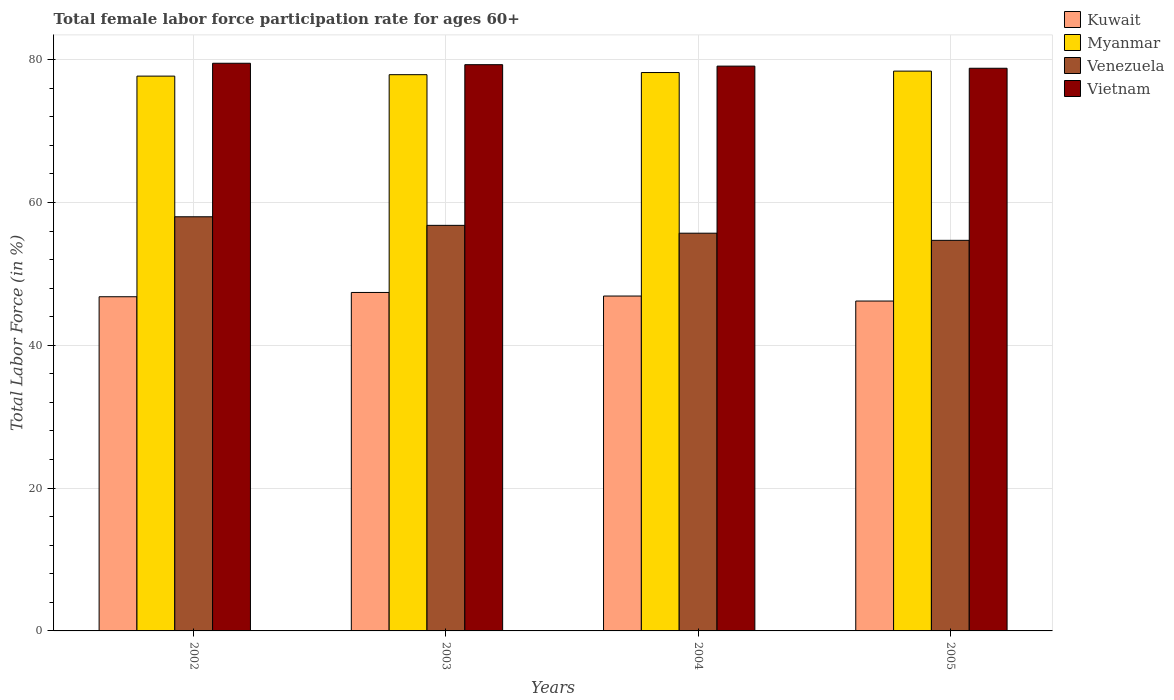How many different coloured bars are there?
Provide a short and direct response. 4. How many groups of bars are there?
Ensure brevity in your answer.  4. Are the number of bars per tick equal to the number of legend labels?
Keep it short and to the point. Yes. How many bars are there on the 3rd tick from the left?
Ensure brevity in your answer.  4. What is the label of the 4th group of bars from the left?
Provide a succinct answer. 2005. What is the female labor force participation rate in Venezuela in 2005?
Offer a terse response. 54.7. Across all years, what is the maximum female labor force participation rate in Kuwait?
Give a very brief answer. 47.4. Across all years, what is the minimum female labor force participation rate in Vietnam?
Ensure brevity in your answer.  78.8. In which year was the female labor force participation rate in Vietnam maximum?
Make the answer very short. 2002. What is the total female labor force participation rate in Venezuela in the graph?
Offer a terse response. 225.2. What is the difference between the female labor force participation rate in Myanmar in 2004 and that in 2005?
Provide a succinct answer. -0.2. What is the difference between the female labor force participation rate in Venezuela in 2002 and the female labor force participation rate in Kuwait in 2004?
Give a very brief answer. 11.1. What is the average female labor force participation rate in Myanmar per year?
Make the answer very short. 78.05. In the year 2003, what is the difference between the female labor force participation rate in Venezuela and female labor force participation rate in Myanmar?
Give a very brief answer. -21.1. What is the ratio of the female labor force participation rate in Venezuela in 2003 to that in 2005?
Keep it short and to the point. 1.04. Is the difference between the female labor force participation rate in Venezuela in 2003 and 2004 greater than the difference between the female labor force participation rate in Myanmar in 2003 and 2004?
Provide a succinct answer. Yes. What is the difference between the highest and the second highest female labor force participation rate in Venezuela?
Keep it short and to the point. 1.2. What is the difference between the highest and the lowest female labor force participation rate in Venezuela?
Your answer should be compact. 3.3. In how many years, is the female labor force participation rate in Venezuela greater than the average female labor force participation rate in Venezuela taken over all years?
Keep it short and to the point. 2. Is the sum of the female labor force participation rate in Vietnam in 2004 and 2005 greater than the maximum female labor force participation rate in Myanmar across all years?
Offer a terse response. Yes. Is it the case that in every year, the sum of the female labor force participation rate in Vietnam and female labor force participation rate in Venezuela is greater than the sum of female labor force participation rate in Kuwait and female labor force participation rate in Myanmar?
Give a very brief answer. No. What does the 1st bar from the left in 2003 represents?
Your answer should be compact. Kuwait. What does the 4th bar from the right in 2005 represents?
Your answer should be compact. Kuwait. Are all the bars in the graph horizontal?
Give a very brief answer. No. Does the graph contain grids?
Offer a very short reply. Yes. Where does the legend appear in the graph?
Offer a very short reply. Top right. How many legend labels are there?
Your answer should be very brief. 4. What is the title of the graph?
Provide a short and direct response. Total female labor force participation rate for ages 60+. Does "Somalia" appear as one of the legend labels in the graph?
Your response must be concise. No. What is the label or title of the Y-axis?
Offer a very short reply. Total Labor Force (in %). What is the Total Labor Force (in %) of Kuwait in 2002?
Offer a very short reply. 46.8. What is the Total Labor Force (in %) in Myanmar in 2002?
Offer a very short reply. 77.7. What is the Total Labor Force (in %) in Venezuela in 2002?
Ensure brevity in your answer.  58. What is the Total Labor Force (in %) in Vietnam in 2002?
Ensure brevity in your answer.  79.5. What is the Total Labor Force (in %) of Kuwait in 2003?
Keep it short and to the point. 47.4. What is the Total Labor Force (in %) in Myanmar in 2003?
Give a very brief answer. 77.9. What is the Total Labor Force (in %) of Venezuela in 2003?
Offer a terse response. 56.8. What is the Total Labor Force (in %) in Vietnam in 2003?
Offer a terse response. 79.3. What is the Total Labor Force (in %) in Kuwait in 2004?
Keep it short and to the point. 46.9. What is the Total Labor Force (in %) of Myanmar in 2004?
Offer a very short reply. 78.2. What is the Total Labor Force (in %) of Venezuela in 2004?
Provide a succinct answer. 55.7. What is the Total Labor Force (in %) in Vietnam in 2004?
Your answer should be compact. 79.1. What is the Total Labor Force (in %) of Kuwait in 2005?
Your answer should be compact. 46.2. What is the Total Labor Force (in %) in Myanmar in 2005?
Make the answer very short. 78.4. What is the Total Labor Force (in %) of Venezuela in 2005?
Your response must be concise. 54.7. What is the Total Labor Force (in %) of Vietnam in 2005?
Your answer should be compact. 78.8. Across all years, what is the maximum Total Labor Force (in %) in Kuwait?
Your answer should be compact. 47.4. Across all years, what is the maximum Total Labor Force (in %) in Myanmar?
Offer a very short reply. 78.4. Across all years, what is the maximum Total Labor Force (in %) in Vietnam?
Make the answer very short. 79.5. Across all years, what is the minimum Total Labor Force (in %) in Kuwait?
Give a very brief answer. 46.2. Across all years, what is the minimum Total Labor Force (in %) of Myanmar?
Make the answer very short. 77.7. Across all years, what is the minimum Total Labor Force (in %) of Venezuela?
Give a very brief answer. 54.7. Across all years, what is the minimum Total Labor Force (in %) in Vietnam?
Offer a very short reply. 78.8. What is the total Total Labor Force (in %) in Kuwait in the graph?
Provide a succinct answer. 187.3. What is the total Total Labor Force (in %) of Myanmar in the graph?
Your response must be concise. 312.2. What is the total Total Labor Force (in %) of Venezuela in the graph?
Keep it short and to the point. 225.2. What is the total Total Labor Force (in %) of Vietnam in the graph?
Keep it short and to the point. 316.7. What is the difference between the Total Labor Force (in %) in Vietnam in 2002 and that in 2003?
Your response must be concise. 0.2. What is the difference between the Total Labor Force (in %) of Venezuela in 2002 and that in 2004?
Provide a short and direct response. 2.3. What is the difference between the Total Labor Force (in %) in Venezuela in 2002 and that in 2005?
Offer a very short reply. 3.3. What is the difference between the Total Labor Force (in %) of Myanmar in 2003 and that in 2004?
Your answer should be very brief. -0.3. What is the difference between the Total Labor Force (in %) in Kuwait in 2003 and that in 2005?
Give a very brief answer. 1.2. What is the difference between the Total Labor Force (in %) of Myanmar in 2003 and that in 2005?
Provide a short and direct response. -0.5. What is the difference between the Total Labor Force (in %) in Venezuela in 2003 and that in 2005?
Offer a very short reply. 2.1. What is the difference between the Total Labor Force (in %) in Kuwait in 2004 and that in 2005?
Your answer should be compact. 0.7. What is the difference between the Total Labor Force (in %) of Myanmar in 2004 and that in 2005?
Give a very brief answer. -0.2. What is the difference between the Total Labor Force (in %) of Venezuela in 2004 and that in 2005?
Offer a terse response. 1. What is the difference between the Total Labor Force (in %) of Vietnam in 2004 and that in 2005?
Give a very brief answer. 0.3. What is the difference between the Total Labor Force (in %) in Kuwait in 2002 and the Total Labor Force (in %) in Myanmar in 2003?
Keep it short and to the point. -31.1. What is the difference between the Total Labor Force (in %) of Kuwait in 2002 and the Total Labor Force (in %) of Venezuela in 2003?
Offer a very short reply. -10. What is the difference between the Total Labor Force (in %) of Kuwait in 2002 and the Total Labor Force (in %) of Vietnam in 2003?
Your answer should be very brief. -32.5. What is the difference between the Total Labor Force (in %) of Myanmar in 2002 and the Total Labor Force (in %) of Venezuela in 2003?
Your response must be concise. 20.9. What is the difference between the Total Labor Force (in %) of Venezuela in 2002 and the Total Labor Force (in %) of Vietnam in 2003?
Ensure brevity in your answer.  -21.3. What is the difference between the Total Labor Force (in %) in Kuwait in 2002 and the Total Labor Force (in %) in Myanmar in 2004?
Make the answer very short. -31.4. What is the difference between the Total Labor Force (in %) of Kuwait in 2002 and the Total Labor Force (in %) of Vietnam in 2004?
Offer a terse response. -32.3. What is the difference between the Total Labor Force (in %) in Myanmar in 2002 and the Total Labor Force (in %) in Venezuela in 2004?
Provide a short and direct response. 22. What is the difference between the Total Labor Force (in %) of Myanmar in 2002 and the Total Labor Force (in %) of Vietnam in 2004?
Ensure brevity in your answer.  -1.4. What is the difference between the Total Labor Force (in %) in Venezuela in 2002 and the Total Labor Force (in %) in Vietnam in 2004?
Offer a terse response. -21.1. What is the difference between the Total Labor Force (in %) of Kuwait in 2002 and the Total Labor Force (in %) of Myanmar in 2005?
Offer a terse response. -31.6. What is the difference between the Total Labor Force (in %) in Kuwait in 2002 and the Total Labor Force (in %) in Vietnam in 2005?
Keep it short and to the point. -32. What is the difference between the Total Labor Force (in %) of Myanmar in 2002 and the Total Labor Force (in %) of Vietnam in 2005?
Your answer should be compact. -1.1. What is the difference between the Total Labor Force (in %) in Venezuela in 2002 and the Total Labor Force (in %) in Vietnam in 2005?
Ensure brevity in your answer.  -20.8. What is the difference between the Total Labor Force (in %) in Kuwait in 2003 and the Total Labor Force (in %) in Myanmar in 2004?
Provide a succinct answer. -30.8. What is the difference between the Total Labor Force (in %) in Kuwait in 2003 and the Total Labor Force (in %) in Venezuela in 2004?
Offer a very short reply. -8.3. What is the difference between the Total Labor Force (in %) in Kuwait in 2003 and the Total Labor Force (in %) in Vietnam in 2004?
Offer a terse response. -31.7. What is the difference between the Total Labor Force (in %) of Myanmar in 2003 and the Total Labor Force (in %) of Vietnam in 2004?
Your answer should be very brief. -1.2. What is the difference between the Total Labor Force (in %) of Venezuela in 2003 and the Total Labor Force (in %) of Vietnam in 2004?
Make the answer very short. -22.3. What is the difference between the Total Labor Force (in %) of Kuwait in 2003 and the Total Labor Force (in %) of Myanmar in 2005?
Provide a succinct answer. -31. What is the difference between the Total Labor Force (in %) of Kuwait in 2003 and the Total Labor Force (in %) of Venezuela in 2005?
Ensure brevity in your answer.  -7.3. What is the difference between the Total Labor Force (in %) in Kuwait in 2003 and the Total Labor Force (in %) in Vietnam in 2005?
Ensure brevity in your answer.  -31.4. What is the difference between the Total Labor Force (in %) of Myanmar in 2003 and the Total Labor Force (in %) of Venezuela in 2005?
Offer a terse response. 23.2. What is the difference between the Total Labor Force (in %) in Venezuela in 2003 and the Total Labor Force (in %) in Vietnam in 2005?
Ensure brevity in your answer.  -22. What is the difference between the Total Labor Force (in %) of Kuwait in 2004 and the Total Labor Force (in %) of Myanmar in 2005?
Make the answer very short. -31.5. What is the difference between the Total Labor Force (in %) in Kuwait in 2004 and the Total Labor Force (in %) in Venezuela in 2005?
Your answer should be compact. -7.8. What is the difference between the Total Labor Force (in %) of Kuwait in 2004 and the Total Labor Force (in %) of Vietnam in 2005?
Your answer should be compact. -31.9. What is the difference between the Total Labor Force (in %) in Myanmar in 2004 and the Total Labor Force (in %) in Vietnam in 2005?
Keep it short and to the point. -0.6. What is the difference between the Total Labor Force (in %) in Venezuela in 2004 and the Total Labor Force (in %) in Vietnam in 2005?
Make the answer very short. -23.1. What is the average Total Labor Force (in %) in Kuwait per year?
Provide a short and direct response. 46.83. What is the average Total Labor Force (in %) in Myanmar per year?
Provide a short and direct response. 78.05. What is the average Total Labor Force (in %) in Venezuela per year?
Provide a short and direct response. 56.3. What is the average Total Labor Force (in %) in Vietnam per year?
Make the answer very short. 79.17. In the year 2002, what is the difference between the Total Labor Force (in %) in Kuwait and Total Labor Force (in %) in Myanmar?
Make the answer very short. -30.9. In the year 2002, what is the difference between the Total Labor Force (in %) in Kuwait and Total Labor Force (in %) in Venezuela?
Keep it short and to the point. -11.2. In the year 2002, what is the difference between the Total Labor Force (in %) of Kuwait and Total Labor Force (in %) of Vietnam?
Ensure brevity in your answer.  -32.7. In the year 2002, what is the difference between the Total Labor Force (in %) in Myanmar and Total Labor Force (in %) in Vietnam?
Offer a very short reply. -1.8. In the year 2002, what is the difference between the Total Labor Force (in %) in Venezuela and Total Labor Force (in %) in Vietnam?
Ensure brevity in your answer.  -21.5. In the year 2003, what is the difference between the Total Labor Force (in %) in Kuwait and Total Labor Force (in %) in Myanmar?
Give a very brief answer. -30.5. In the year 2003, what is the difference between the Total Labor Force (in %) in Kuwait and Total Labor Force (in %) in Vietnam?
Offer a terse response. -31.9. In the year 2003, what is the difference between the Total Labor Force (in %) in Myanmar and Total Labor Force (in %) in Venezuela?
Offer a terse response. 21.1. In the year 2003, what is the difference between the Total Labor Force (in %) of Myanmar and Total Labor Force (in %) of Vietnam?
Give a very brief answer. -1.4. In the year 2003, what is the difference between the Total Labor Force (in %) of Venezuela and Total Labor Force (in %) of Vietnam?
Offer a very short reply. -22.5. In the year 2004, what is the difference between the Total Labor Force (in %) of Kuwait and Total Labor Force (in %) of Myanmar?
Your answer should be very brief. -31.3. In the year 2004, what is the difference between the Total Labor Force (in %) of Kuwait and Total Labor Force (in %) of Vietnam?
Offer a very short reply. -32.2. In the year 2004, what is the difference between the Total Labor Force (in %) of Myanmar and Total Labor Force (in %) of Vietnam?
Give a very brief answer. -0.9. In the year 2004, what is the difference between the Total Labor Force (in %) in Venezuela and Total Labor Force (in %) in Vietnam?
Your response must be concise. -23.4. In the year 2005, what is the difference between the Total Labor Force (in %) in Kuwait and Total Labor Force (in %) in Myanmar?
Your response must be concise. -32.2. In the year 2005, what is the difference between the Total Labor Force (in %) of Kuwait and Total Labor Force (in %) of Venezuela?
Your answer should be very brief. -8.5. In the year 2005, what is the difference between the Total Labor Force (in %) of Kuwait and Total Labor Force (in %) of Vietnam?
Provide a short and direct response. -32.6. In the year 2005, what is the difference between the Total Labor Force (in %) of Myanmar and Total Labor Force (in %) of Venezuela?
Offer a terse response. 23.7. In the year 2005, what is the difference between the Total Labor Force (in %) of Venezuela and Total Labor Force (in %) of Vietnam?
Keep it short and to the point. -24.1. What is the ratio of the Total Labor Force (in %) in Kuwait in 2002 to that in 2003?
Offer a terse response. 0.99. What is the ratio of the Total Labor Force (in %) in Venezuela in 2002 to that in 2003?
Your answer should be very brief. 1.02. What is the ratio of the Total Labor Force (in %) of Kuwait in 2002 to that in 2004?
Give a very brief answer. 1. What is the ratio of the Total Labor Force (in %) of Venezuela in 2002 to that in 2004?
Keep it short and to the point. 1.04. What is the ratio of the Total Labor Force (in %) of Kuwait in 2002 to that in 2005?
Your answer should be very brief. 1.01. What is the ratio of the Total Labor Force (in %) of Venezuela in 2002 to that in 2005?
Offer a very short reply. 1.06. What is the ratio of the Total Labor Force (in %) in Vietnam in 2002 to that in 2005?
Provide a short and direct response. 1.01. What is the ratio of the Total Labor Force (in %) of Kuwait in 2003 to that in 2004?
Your answer should be compact. 1.01. What is the ratio of the Total Labor Force (in %) of Venezuela in 2003 to that in 2004?
Provide a short and direct response. 1.02. What is the ratio of the Total Labor Force (in %) of Vietnam in 2003 to that in 2004?
Your answer should be very brief. 1. What is the ratio of the Total Labor Force (in %) of Venezuela in 2003 to that in 2005?
Provide a succinct answer. 1.04. What is the ratio of the Total Labor Force (in %) in Vietnam in 2003 to that in 2005?
Give a very brief answer. 1.01. What is the ratio of the Total Labor Force (in %) of Kuwait in 2004 to that in 2005?
Keep it short and to the point. 1.02. What is the ratio of the Total Labor Force (in %) of Venezuela in 2004 to that in 2005?
Provide a succinct answer. 1.02. What is the difference between the highest and the second highest Total Labor Force (in %) in Vietnam?
Your answer should be very brief. 0.2. What is the difference between the highest and the lowest Total Labor Force (in %) in Myanmar?
Give a very brief answer. 0.7. 